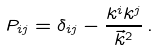<formula> <loc_0><loc_0><loc_500><loc_500>P _ { i j } = \delta _ { i j } - \frac { k ^ { i } k ^ { j } } { \vec { k } ^ { 2 } } \, .</formula> 